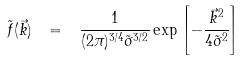Convert formula to latex. <formula><loc_0><loc_0><loc_500><loc_500>\tilde { f } ( \vec { k } ) \ = \ \frac { 1 } { ( 2 \pi ) ^ { 3 / 4 } \tilde { \sigma } ^ { 3 / 2 } } \exp { \left [ - \frac { \vec { k } ^ { 2 } } { 4 \tilde { \sigma } ^ { 2 } } \right ] }</formula> 